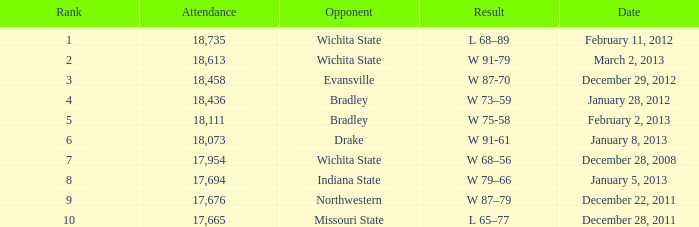What is the position for february 11, 2012 with under 18,735 attendees? None. 